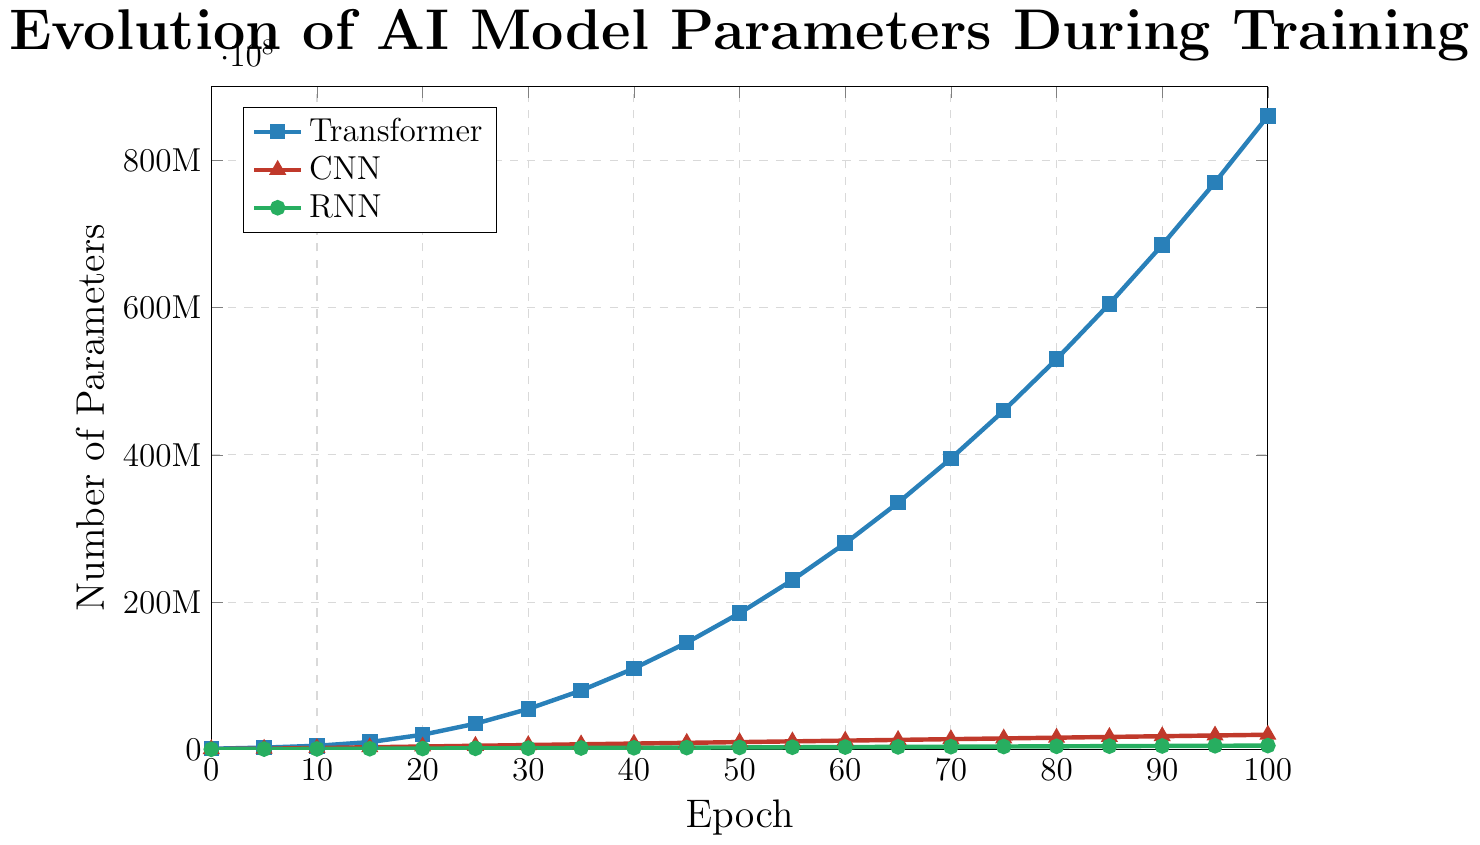What is the number of parameters for the Transformer at epoch 50? Looking at the graph, we can see the value for Transformer at epoch 50.
Answer: 185,000,000 Which model architecture has the highest number of parameters at epoch 20? By observing the y-axis at epoch 20 and comparing the height of the three different plots, the Transformer has the highest number of parameters.
Answer: Transformer At epoch 0, how many more parameters does the Transformer have compared to the RNN? The Transformer has 1,000,000 parameters, and the RNN has 250,000 parameters at epoch 0. The difference is 1,000,000 - 250,000.
Answer: 750,000 Do the number of parameters for CNN ever exceed 20 million during training? Checking the graph, the maximum value for CNN, which occurs at epoch 100, is 20,000,000. It never exceeds 20 million.
Answer: No What is the difference in the number of parameters between CNN and RNN at epoch 75? The CNN has 15,000,000 parameters, and the RNN has 4,000,000 parameters at epoch 75. The difference is 15,000,000 - 4,000,000.
Answer: 11,000,000 How much do the parameters of the Transformer increase from epoch 60 to epoch 90? At epoch 60, the Transformer has 280,000,000 parameters, and at epoch 90, it has 685,000,000 parameters. The increase is 685,000,000 - 280,000,000.
Answer: 405,000,000 Which data point corresponds to the red-colored plot at epoch 55? The red-colored plot represents the CNN. At epoch 55, the CNN has 11,000,000 parameters.
Answer: 11,000,000 What is the slope of the RNN curve between epoch 40 and epoch 60? We find the change in parameters and the number of epochs: (3,250,000 - 2,250,000) / (60 - 40).
Answer: 50,000 Which model has the steepest increase in parameters between epoch 45 and epoch 50? The Transformer increases from 145,000,000 to 185,000,000, CNN from 9,000,000 to 10,000,000, and RNN from 2,500,000 to 2,750,000. The Transformer has the steepest increase.
Answer: Transformer 